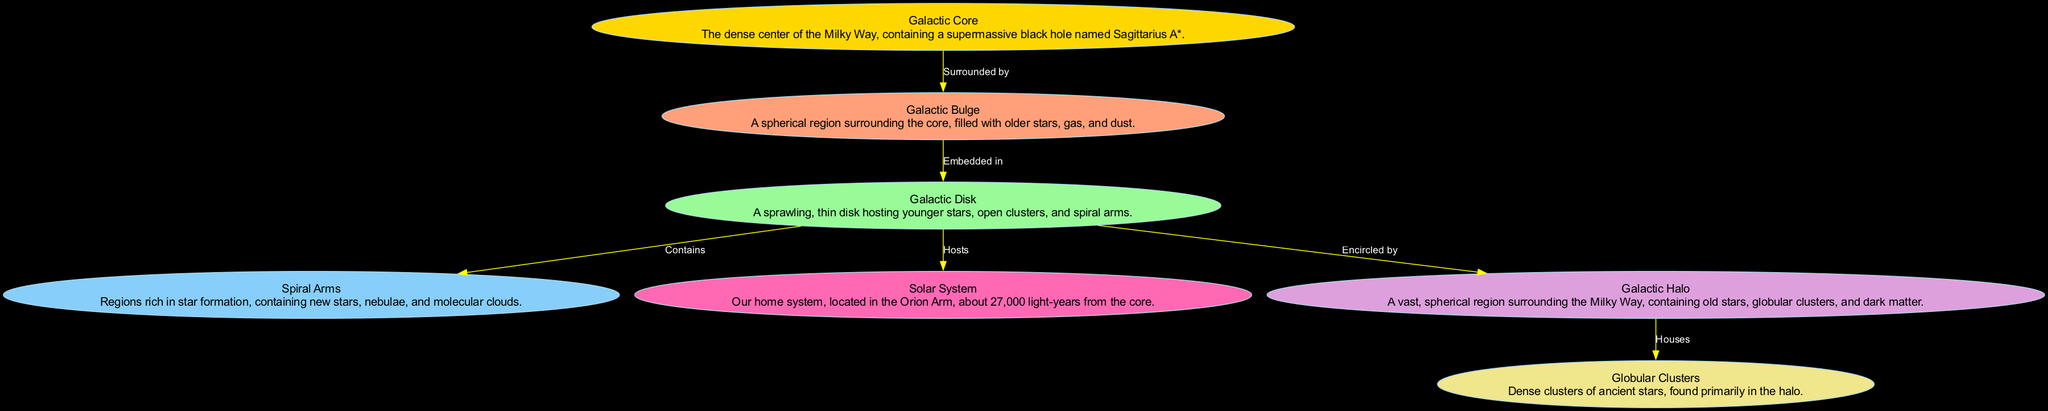What is at the center of the Milky Way? The diagram specifies that the Galactic Core is at the center of the Milky Way, where a supermassive black hole named Sagittarius A* is located.
Answer: Galactic Core How many main regions are depicted in the diagram? The diagram illustrates six main regions/structures: Galactic Core, Galactic Bulge, Galactic Disk, Spiral Arms, Solar System, Galactic Halo, and Globular Clusters. Counting these gives a total of six.
Answer: 6 Which region is surrounded by the Galactic Core? According to the diagram, the Galactic Core is surrounded by the Galactic Bulge. The edge leading from the Core to the Bulge indicates this relationship clearly.
Answer: Galactic Bulge What region does the Galactic Disk host? The diagram shows that the Galactic Disk hosts the Solar System. The edge connecting the Disk to the Solar System indicates that this relationship exists.
Answer: Solar System What is located in the Galactic Halo? The diagram indicates that the Galactic Halo houses Globular Clusters. This connection is depicted through the labeled edge leading from the Halo to the Globular Clusters.
Answer: Globular Clusters What type of stars primarily populate the Galactic Bulge? From the diagram, it can be understood that the Galactic Bulge is filled with older stars, gas, and dust, which is explicitly stated in the Bulge's description.
Answer: Older stars What is a characteristic feature of the Spiral Arms? The description provided in the Spiral Arms part of the diagram notes that they are regions rich in star formation, which indicates that new stars and nebulae are significant features of these arms.
Answer: Star formation Which region encircles the Galactic Disk? The diagram clearly states that the Galactic Halo encircles the Galactic Disk, as marked by the labeled edge showing this relationship.
Answer: Galactic Halo What type of stars are mainly found in the Globular Clusters? The information in the Globular Clusters section of the diagram specifies that they contain ancient stars, characterizing them as primarily composed of these types of stars.
Answer: Ancient stars 